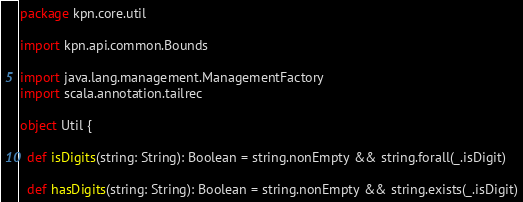<code> <loc_0><loc_0><loc_500><loc_500><_Scala_>package kpn.core.util

import kpn.api.common.Bounds

import java.lang.management.ManagementFactory
import scala.annotation.tailrec

object Util {

  def isDigits(string: String): Boolean = string.nonEmpty && string.forall(_.isDigit)

  def hasDigits(string: String): Boolean = string.nonEmpty && string.exists(_.isDigit)
</code> 